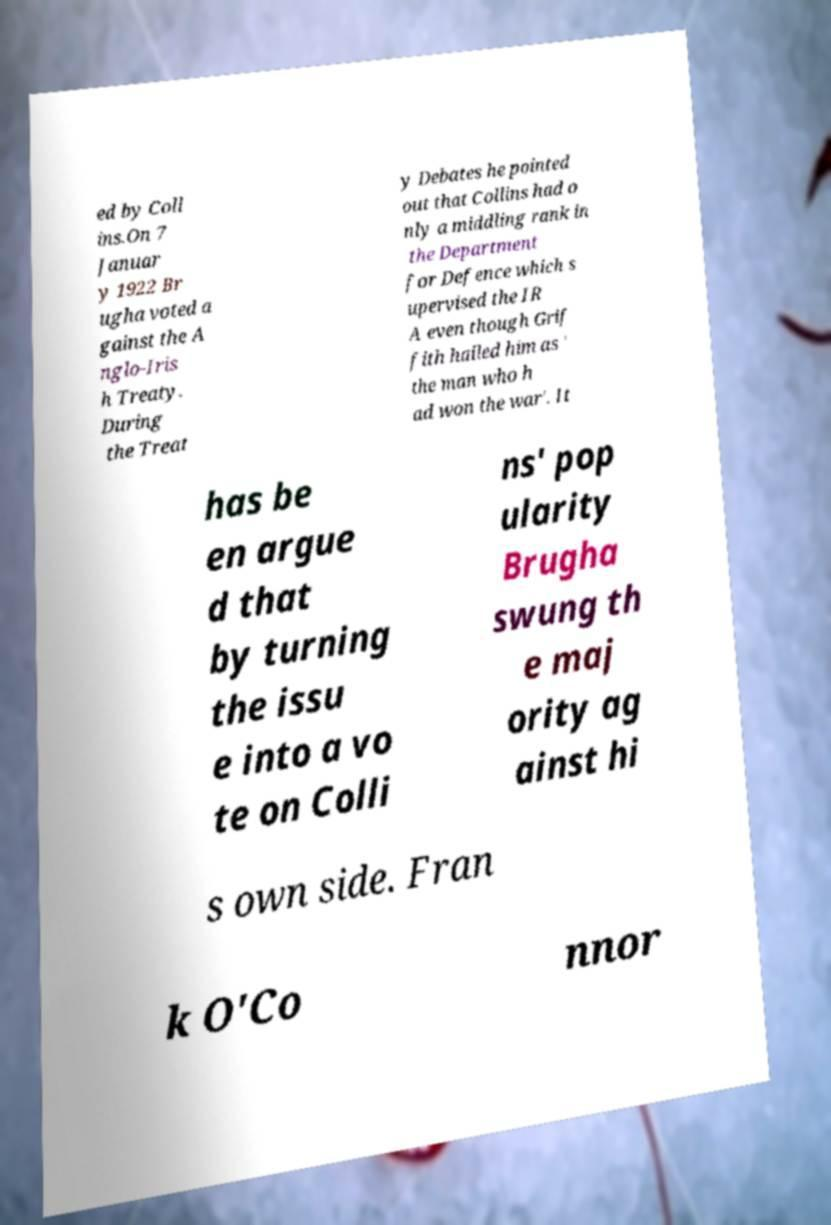Could you extract and type out the text from this image? ed by Coll ins.On 7 Januar y 1922 Br ugha voted a gainst the A nglo-Iris h Treaty. During the Treat y Debates he pointed out that Collins had o nly a middling rank in the Department for Defence which s upervised the IR A even though Grif fith hailed him as ' the man who h ad won the war'. It has be en argue d that by turning the issu e into a vo te on Colli ns' pop ularity Brugha swung th e maj ority ag ainst hi s own side. Fran k O'Co nnor 